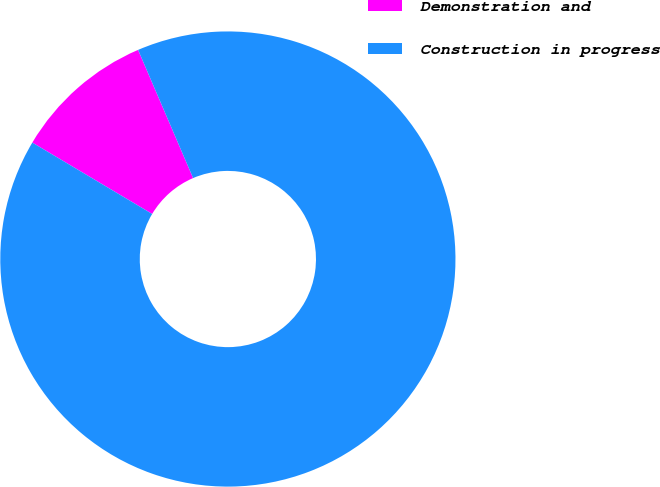Convert chart. <chart><loc_0><loc_0><loc_500><loc_500><pie_chart><fcel>Demonstration and<fcel>Construction in progress<nl><fcel>10.0%<fcel>90.0%<nl></chart> 